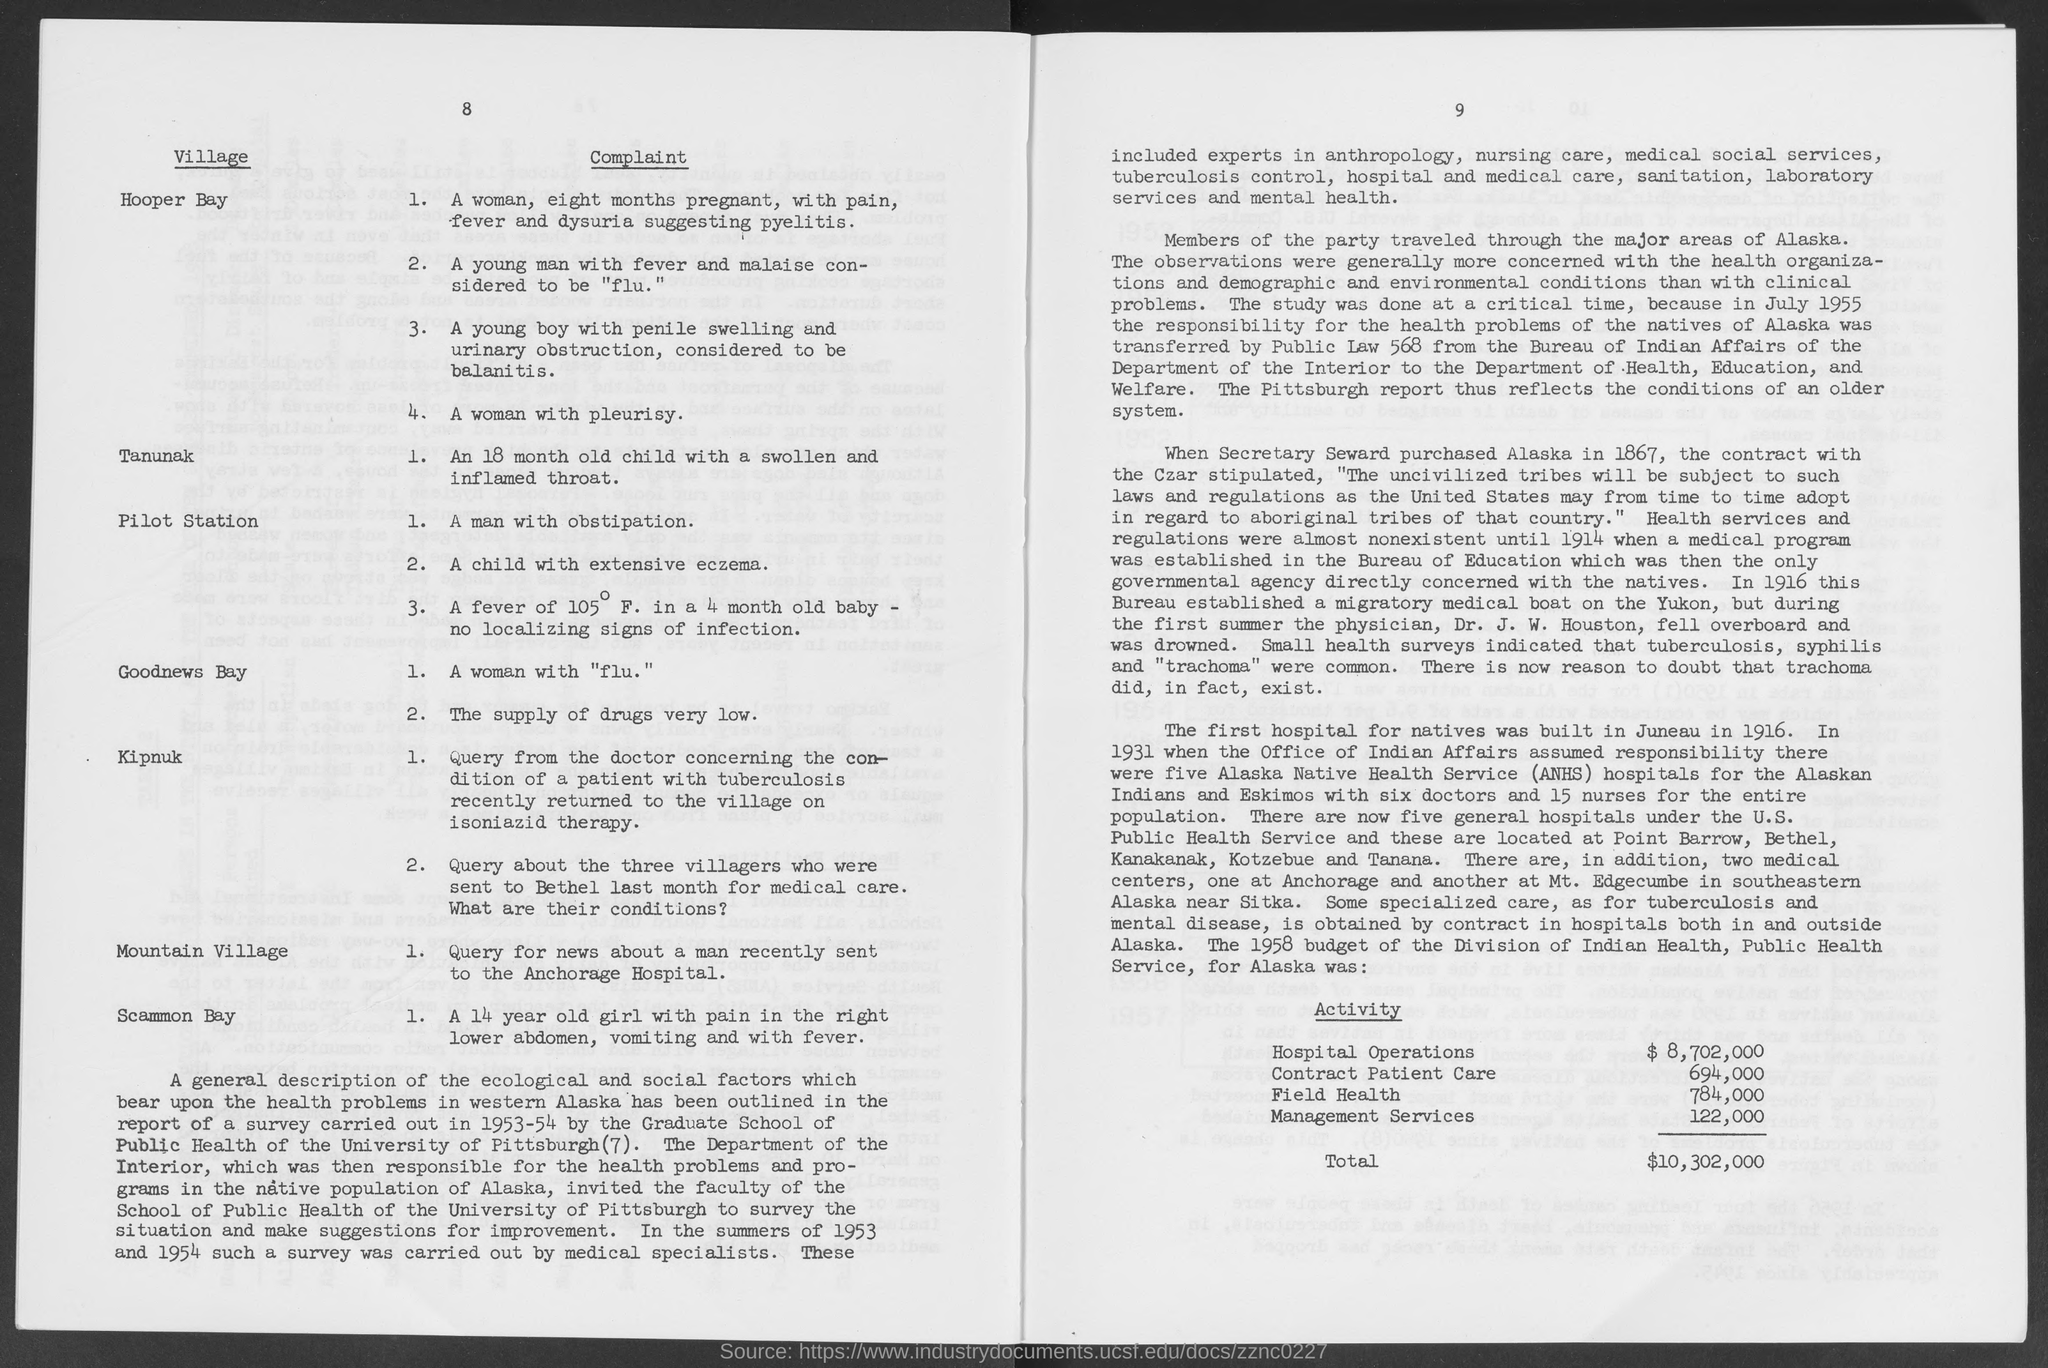Give some essential details in this illustration. In the 1958 budget, funding was allocated for contract patient care activity in Alaska, totaling $694,000. The 1958 budget for hospital operations activity in Alaska was $8,702,000. In 1958, the budget for management services activity in Alaska was $122,000. Alaska Native Health Service (ANHS) is a healthcare provider that serves the Alaska Native and Native American communities in the state of Alaska. The budget for Field Health activity in Alaska for the year 1958 was $784,000. 